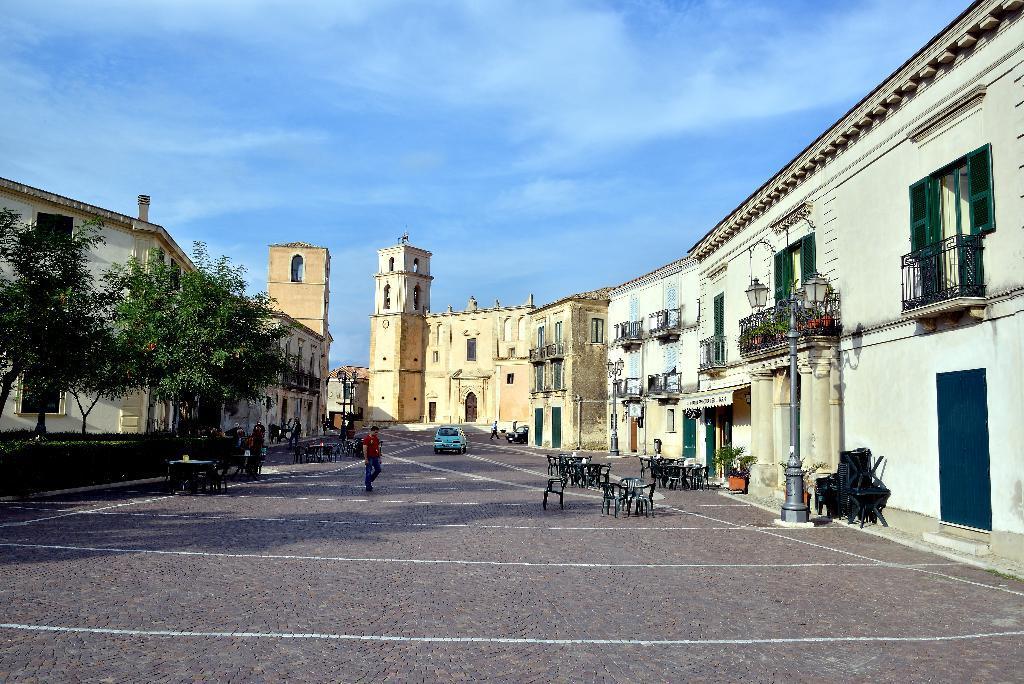Can you describe this image briefly? In this image I can see a person walking on the road. I can see few chairs. There are few buildings. I can see few trees. I can see a car. At the top I can see clouds in the sky. 